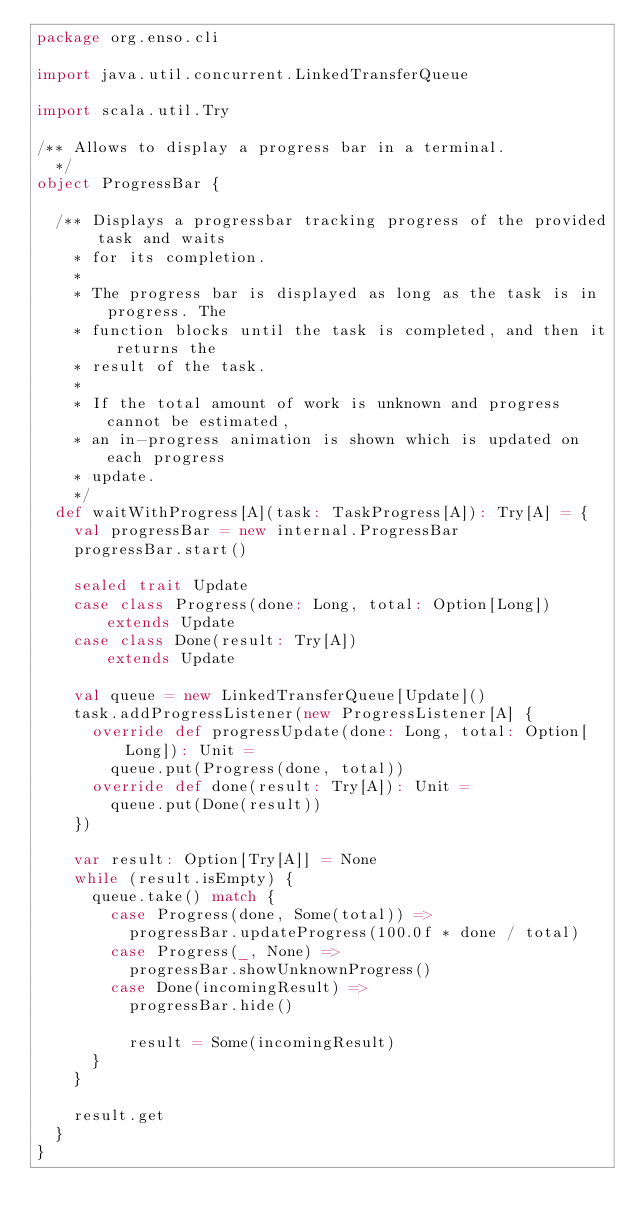Convert code to text. <code><loc_0><loc_0><loc_500><loc_500><_Scala_>package org.enso.cli

import java.util.concurrent.LinkedTransferQueue

import scala.util.Try

/** Allows to display a progress bar in a terminal.
  */
object ProgressBar {

  /** Displays a progressbar tracking progress of the provided task and waits
    * for its completion.
    *
    * The progress bar is displayed as long as the task is in progress. The
    * function blocks until the task is completed, and then it returns the
    * result of the task.
    *
    * If the total amount of work is unknown and progress cannot be estimated,
    * an in-progress animation is shown which is updated on each progress
    * update.
    */
  def waitWithProgress[A](task: TaskProgress[A]): Try[A] = {
    val progressBar = new internal.ProgressBar
    progressBar.start()

    sealed trait Update
    case class Progress(done: Long, total: Option[Long]) extends Update
    case class Done(result: Try[A])                      extends Update

    val queue = new LinkedTransferQueue[Update]()
    task.addProgressListener(new ProgressListener[A] {
      override def progressUpdate(done: Long, total: Option[Long]): Unit =
        queue.put(Progress(done, total))
      override def done(result: Try[A]): Unit =
        queue.put(Done(result))
    })

    var result: Option[Try[A]] = None
    while (result.isEmpty) {
      queue.take() match {
        case Progress(done, Some(total)) =>
          progressBar.updateProgress(100.0f * done / total)
        case Progress(_, None) =>
          progressBar.showUnknownProgress()
        case Done(incomingResult) =>
          progressBar.hide()

          result = Some(incomingResult)
      }
    }

    result.get
  }
}
</code> 